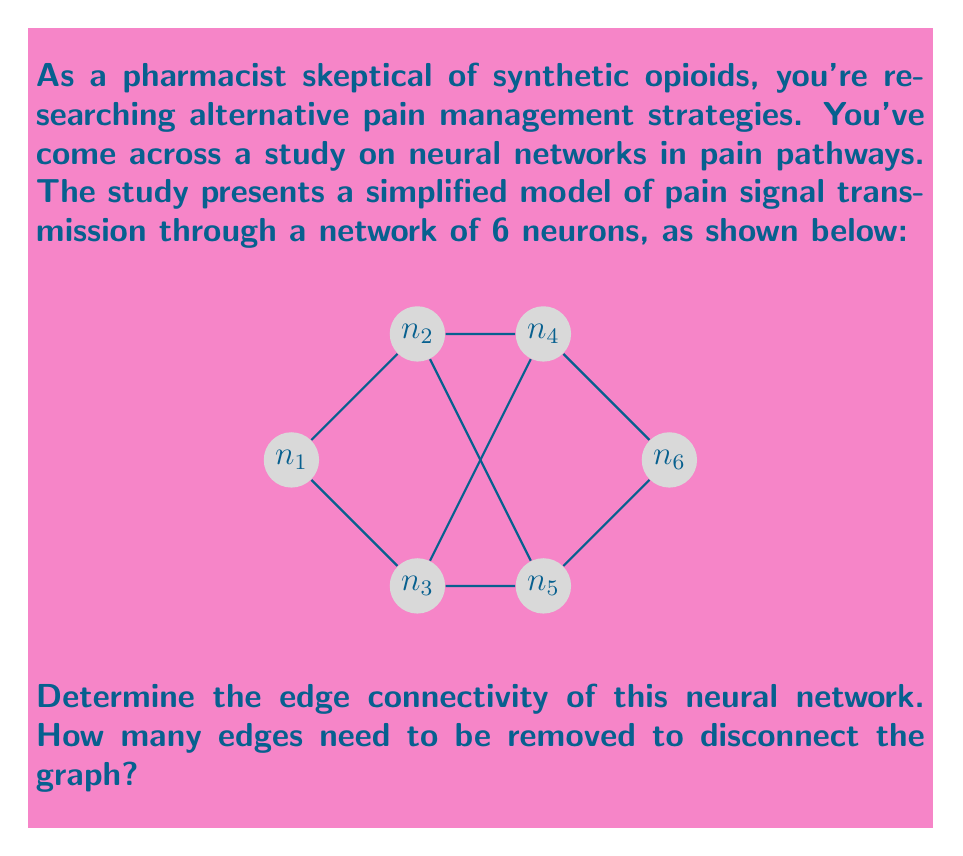Solve this math problem. To solve this problem, we need to understand the concept of edge connectivity in graph theory and apply it to the given neural network model.

Step 1: Understand edge connectivity
Edge connectivity is the minimum number of edges that need to be removed to disconnect a graph. It's a measure of how well-connected a graph is.

Step 2: Analyze the graph structure
The graph has 6 vertices (neurons) and 7 edges (connections between neurons).

Step 3: Identify potential cuts
To disconnect the graph, we need to find the minimum number of edges that, when removed, will separate the graph into two or more components. Let's consider the possible cuts:

a) Removing edges from $n_1$: We need to remove at least 2 edges ($(n_1,n_2)$ and $(n_1,n_3)$) to isolate $n_1$.
b) Removing edges from $n_6$: Similarly, we need to remove at least 2 edges ($(n_5,n_6)$ and $(n_4,n_6)$) to isolate $n_6$.
c) Removing middle edges: We can disconnect the graph by removing $(n_2,n_4)$ and $(n_3,n_5)$.

Step 4: Determine the minimum cut
The minimum number of edges we need to remove to disconnect the graph is 2. This can be achieved by removing $(n_2,n_4)$ and $(n_3,n_5)$, which will separate the graph into two components: $\{n_1,n_2,n_3\}$ and $\{n_4,n_5,n_6\}$.

Step 5: Verify
There is no way to disconnect the graph by removing only one edge, as there are always alternative paths between any two nodes.

Therefore, the edge connectivity of this neural network is 2.
Answer: 2 